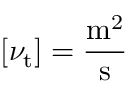<formula> <loc_0><loc_0><loc_500><loc_500>\left [ \nu _ { t } \right ] = { \frac { m ^ { 2 } } { s } }</formula> 